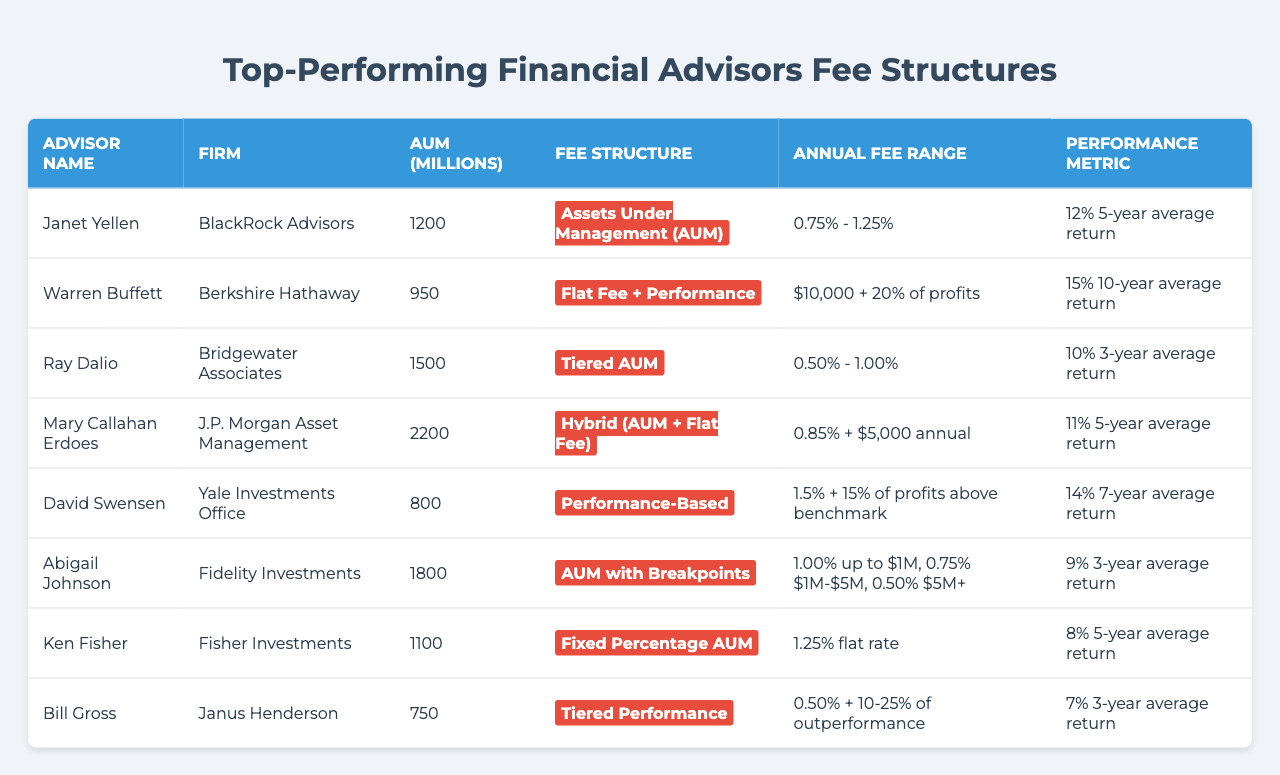What is the fee range for Janet Yellen's advisory services? According to the table, Janet Yellen has a fee structure of "Assets Under Management (AUM)", and the annual fee range for her services is "0.75% - 1.25%".
Answer: 0.75% - 1.25% Which advisor has the highest Assets Under Management (AUM)? By examining the table, we see the AUM values listed: 1200, 950, 1500, 2200, 800, 1800, 1100, and 750 millions. The highest AUM is 2200 million, attributed to Mary Callahan Erdoes.
Answer: Mary Callahan Erdoes Is the fee structure for David Swensen solely performance-based? The table indicates that David Swensen's fee structure is "Performance-Based", which includes "1.5% + 15% of profits above benchmark". Thus, it is indeed performance-based but not solely.
Answer: No What is the difference in average return between Warren Buffett and Ken Fisher? Warren Buffett has a 15% 10-year average return, while Ken Fisher has an 8% 5-year average return. The difference is calculated as 15% - 8% = 7%.
Answer: 7% How many advisors use a tiered fee structure? By reviewing the table, Ray Dalio uses "Tiered AUM" and Bill Gross uses "Tiered Performance", making a total of two advisors with a tiered fee structure.
Answer: 2 Which advisor has the lowest reported annual fee range, and what is that range? The advisor with the lowest annual fee range is Ray Dalio, with "0.50% - 1.00%".
Answer: 0.50% - 1.00% What are the average returns of advisors who have AUM solely and performance-based fee structures? The average return for those with solely AUM structures (Janet Yellen, Ray Dalio, Abigail Johnson, Ken Fisher) is (12% + 10% + 9% + 8%) / 4 = 9.75%, while for performance-based (Warren Buffett and David Swensen), it's (15% + 14%) / 2 = 14.5%.
Answer: AUM: 9.75%, Performance-based: 14.5% Which financial advisor has the most varied fee structure type? Based on the table, Mary Callahan Erdoes uses the "Hybrid (AUM + Flat Fee)" structure, which combines aspects of both AUM and flat fees. This type indicates a more varied fee structure.
Answer: Mary Callahan Erdoes Is there any advisor in the table whose annual fee includes a specific flat fee? Looking at the table, both Warren Buffett and Mary Callahan Erdoes have flat fees included in their annual fees: "$10,000 + 20% of profits" for Buffett and "$5,000 annual" for Erdoes.
Answer: Yes What performance metric reflects the lowest average return in the table? The performance metric reflecting the lowest average return is found under Ken Fisher, whose return is listed as "8% 5-year average return".
Answer: 8% 